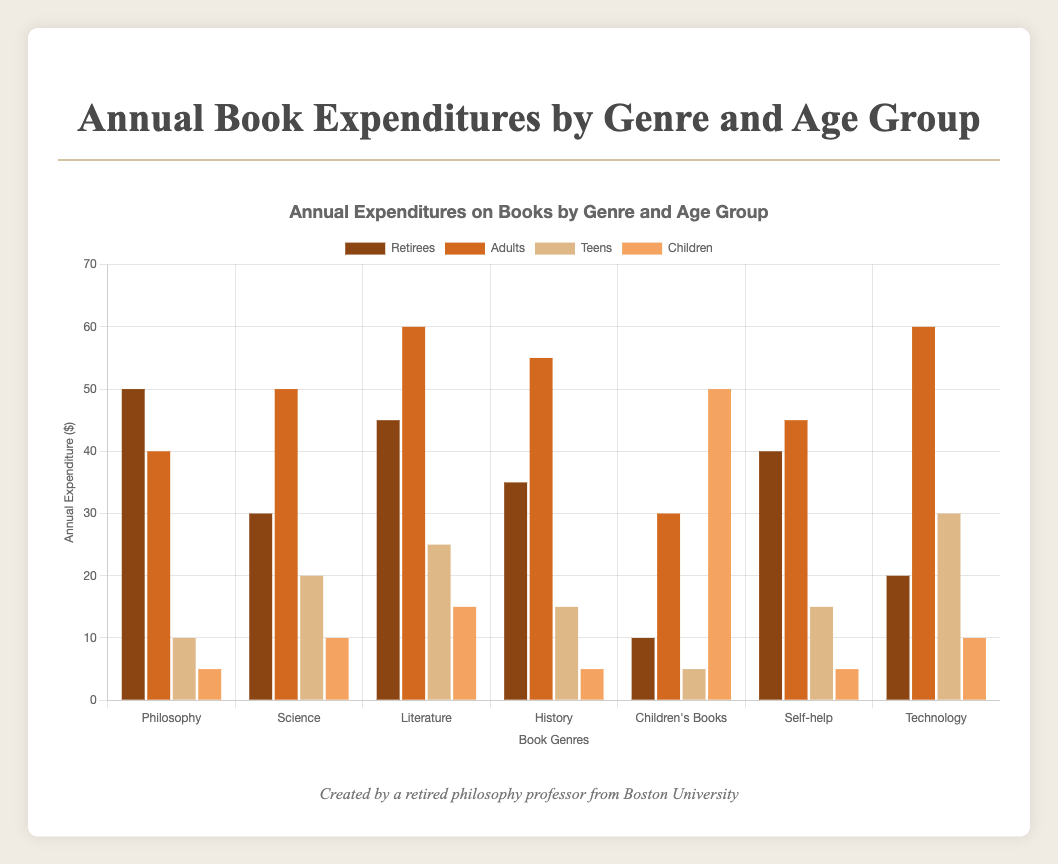What's the overall expenditure on Philosophy books by all age groups? Add the expenditures for Philosophy books by retirees (50), adults (40), teens (10), and children (5): 50 + 40 + 10 + 5 = 105
Answer: 105 Which age group spends the most on Philosophy books? Look at the height of the bars for Philosophy books. The highest bar corresponds to retirees, who spend 50
Answer: Retirees How does the expenditure on Science books by retirees compare to that by adults? The bar for retirees' expenditure on Science books is at 30, while the bar for adults is at 50. Clearly, retirees spend less than adults
Answer: Retirees spend less Which genre has the lowest expenditure by children? Compare the bars representing children's expenditure across genres. The lowest bar is linked to Philosophy and History, both showing an expenditure of 5
Answer: Philosophy, History What's the average expenditure on Literature books across all age groups? Add the expenditures for Literature books by retirees (45), adults (60), teens (25), and children (15). Then divide by the number of groups: (45 + 60 + 25 + 15) / 4 = 145 / 4 = 36.25
Answer: 36.25 What is the total expenditure on books by retirees? Add the expenditures by retirees across all genres: 50 (Philosophy) + 30 (Science) + 45 (Literature) + 35 (History) + 10 (Children's Books) + 40 (Self-help) + 20 (Technology) = 230
Answer: 230 Are there any genres where teens spend as much as retirees? Compare the heights of the bars for teens and retirees across genres. For Technology, both groups spend 20
Answer: Technology What genre shows the highest overall expenditure, combining all age groups? Sum the expenditures across all age groups for each genre. Literature: (45 + 60 + 25 + 15) = 145, which is the highest among all genres
Answer: Literature 